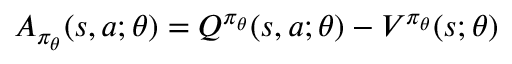Convert formula to latex. <formula><loc_0><loc_0><loc_500><loc_500>A _ { \pi _ { \theta } } ( s , a ; \theta ) = Q ^ { \pi _ { \theta } } ( s , a ; \theta ) - V ^ { \pi _ { \theta } } ( s ; \theta )</formula> 